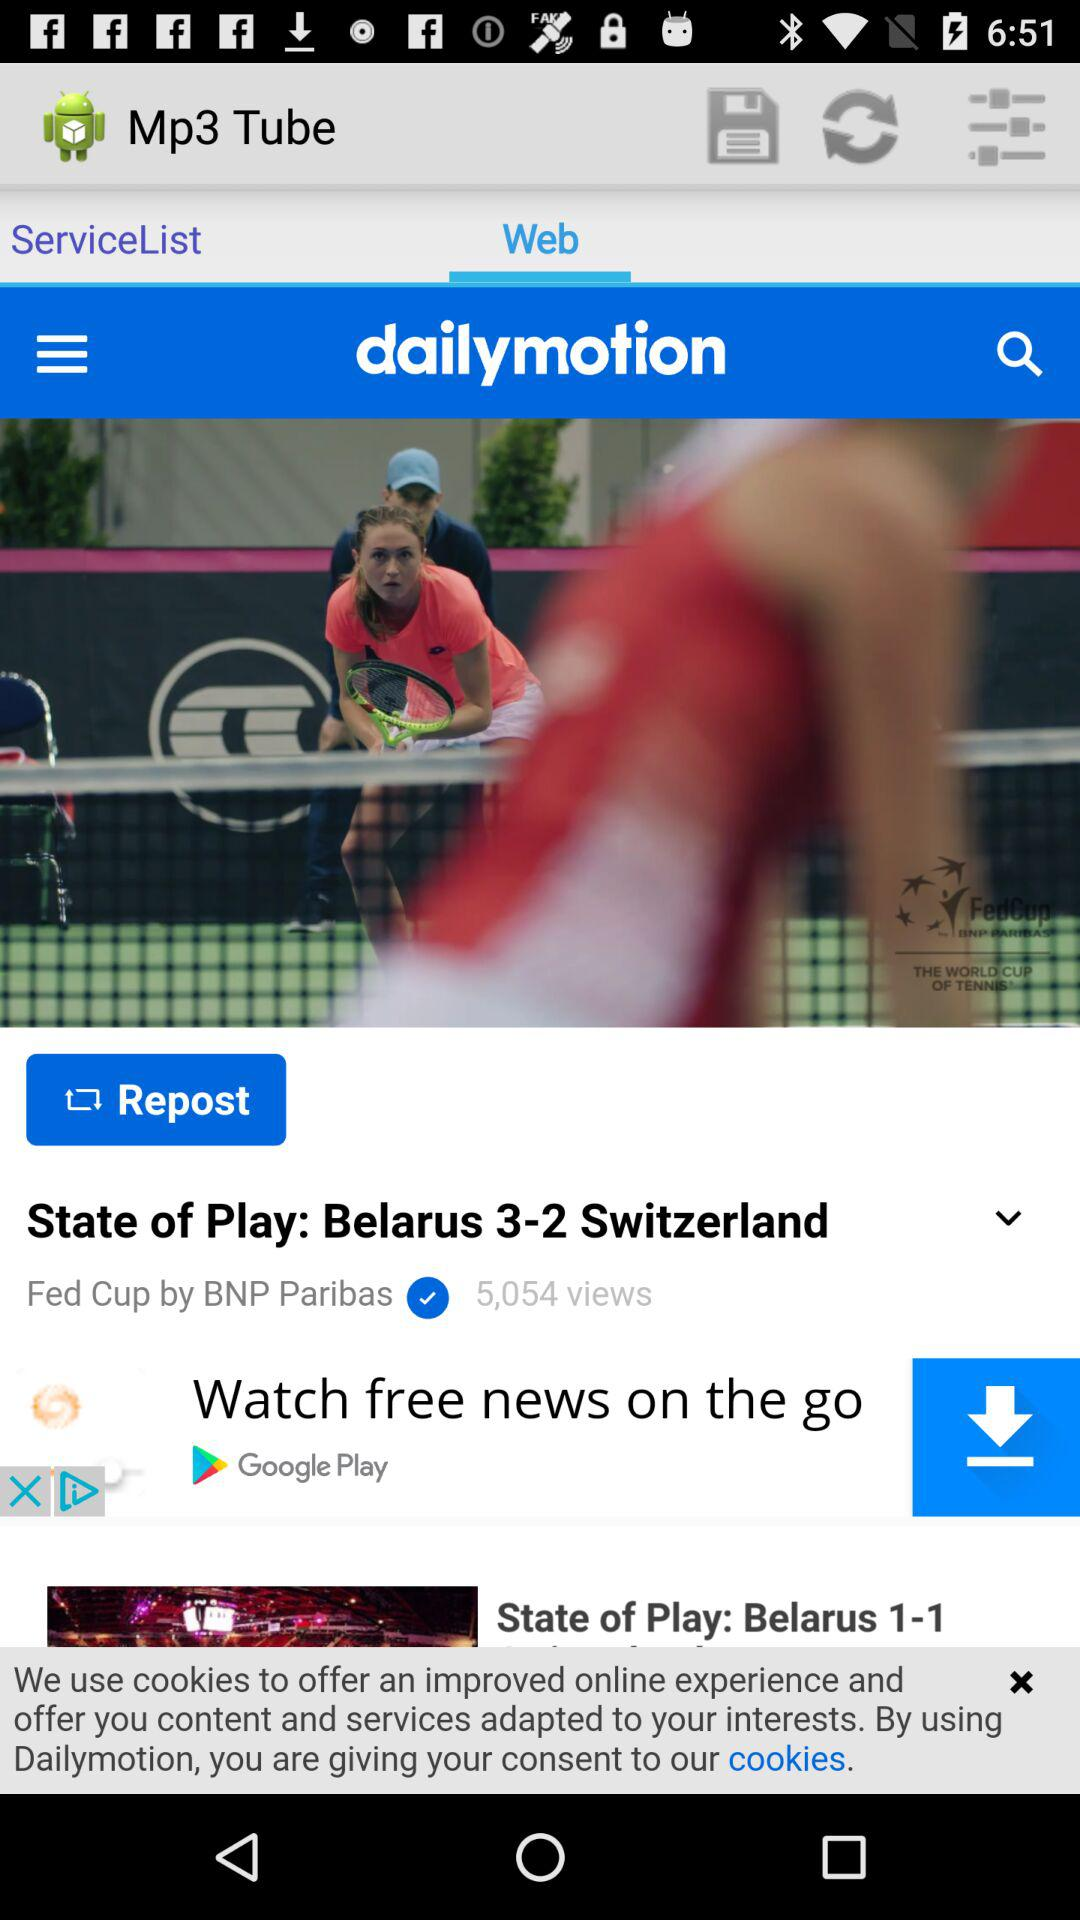Which option is selected? The selected option is "Web". 